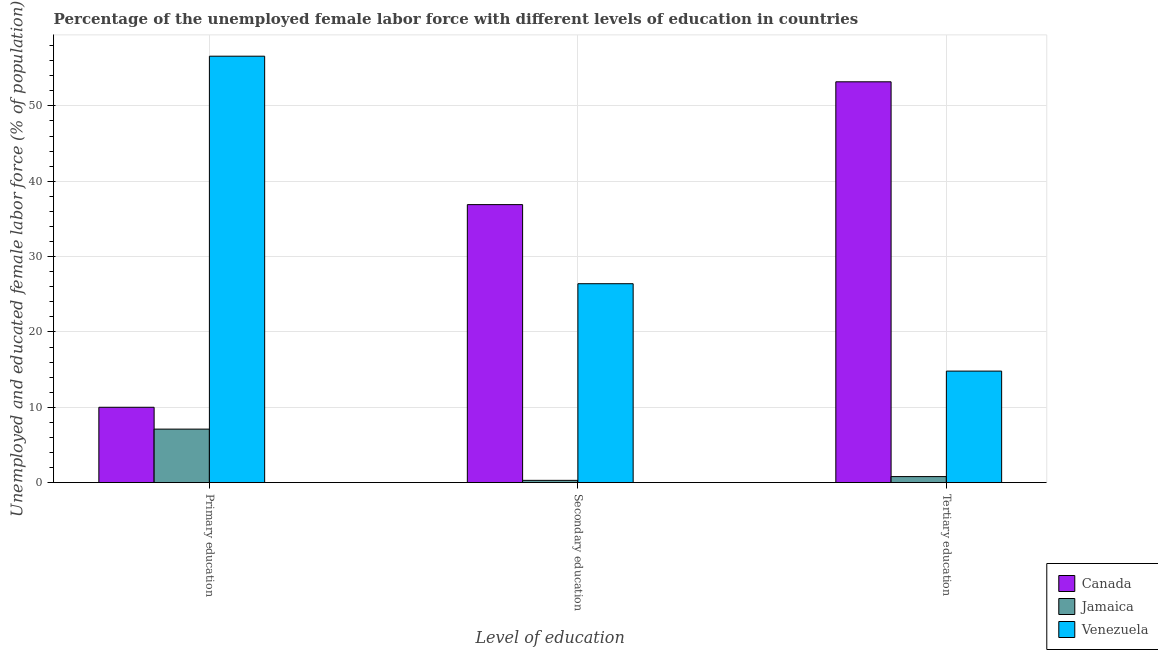How many groups of bars are there?
Provide a short and direct response. 3. Are the number of bars on each tick of the X-axis equal?
Your answer should be compact. Yes. How many bars are there on the 1st tick from the right?
Offer a very short reply. 3. What is the label of the 2nd group of bars from the left?
Give a very brief answer. Secondary education. What is the percentage of female labor force who received tertiary education in Venezuela?
Offer a very short reply. 14.8. Across all countries, what is the maximum percentage of female labor force who received primary education?
Make the answer very short. 56.6. Across all countries, what is the minimum percentage of female labor force who received secondary education?
Your answer should be compact. 0.3. In which country was the percentage of female labor force who received secondary education maximum?
Your response must be concise. Canada. In which country was the percentage of female labor force who received secondary education minimum?
Make the answer very short. Jamaica. What is the total percentage of female labor force who received secondary education in the graph?
Keep it short and to the point. 63.6. What is the difference between the percentage of female labor force who received tertiary education in Jamaica and that in Venezuela?
Make the answer very short. -14. What is the difference between the percentage of female labor force who received tertiary education in Venezuela and the percentage of female labor force who received primary education in Jamaica?
Offer a terse response. 7.7. What is the average percentage of female labor force who received primary education per country?
Your answer should be compact. 24.57. What is the difference between the percentage of female labor force who received secondary education and percentage of female labor force who received tertiary education in Venezuela?
Ensure brevity in your answer.  11.6. What is the ratio of the percentage of female labor force who received primary education in Canada to that in Jamaica?
Offer a very short reply. 1.41. What is the difference between the highest and the second highest percentage of female labor force who received primary education?
Make the answer very short. 46.6. What is the difference between the highest and the lowest percentage of female labor force who received secondary education?
Keep it short and to the point. 36.6. Is the sum of the percentage of female labor force who received secondary education in Jamaica and Venezuela greater than the maximum percentage of female labor force who received primary education across all countries?
Keep it short and to the point. No. What does the 2nd bar from the right in Tertiary education represents?
Make the answer very short. Jamaica. Are all the bars in the graph horizontal?
Your answer should be very brief. No. What is the difference between two consecutive major ticks on the Y-axis?
Provide a succinct answer. 10. Does the graph contain any zero values?
Provide a succinct answer. No. Where does the legend appear in the graph?
Offer a terse response. Bottom right. How many legend labels are there?
Your response must be concise. 3. How are the legend labels stacked?
Keep it short and to the point. Vertical. What is the title of the graph?
Provide a succinct answer. Percentage of the unemployed female labor force with different levels of education in countries. Does "St. Martin (French part)" appear as one of the legend labels in the graph?
Give a very brief answer. No. What is the label or title of the X-axis?
Give a very brief answer. Level of education. What is the label or title of the Y-axis?
Give a very brief answer. Unemployed and educated female labor force (% of population). What is the Unemployed and educated female labor force (% of population) of Canada in Primary education?
Give a very brief answer. 10. What is the Unemployed and educated female labor force (% of population) in Jamaica in Primary education?
Ensure brevity in your answer.  7.1. What is the Unemployed and educated female labor force (% of population) in Venezuela in Primary education?
Offer a terse response. 56.6. What is the Unemployed and educated female labor force (% of population) of Canada in Secondary education?
Keep it short and to the point. 36.9. What is the Unemployed and educated female labor force (% of population) of Jamaica in Secondary education?
Give a very brief answer. 0.3. What is the Unemployed and educated female labor force (% of population) of Venezuela in Secondary education?
Give a very brief answer. 26.4. What is the Unemployed and educated female labor force (% of population) in Canada in Tertiary education?
Provide a succinct answer. 53.2. What is the Unemployed and educated female labor force (% of population) of Jamaica in Tertiary education?
Provide a short and direct response. 0.8. What is the Unemployed and educated female labor force (% of population) of Venezuela in Tertiary education?
Give a very brief answer. 14.8. Across all Level of education, what is the maximum Unemployed and educated female labor force (% of population) of Canada?
Your response must be concise. 53.2. Across all Level of education, what is the maximum Unemployed and educated female labor force (% of population) in Jamaica?
Provide a succinct answer. 7.1. Across all Level of education, what is the maximum Unemployed and educated female labor force (% of population) in Venezuela?
Keep it short and to the point. 56.6. Across all Level of education, what is the minimum Unemployed and educated female labor force (% of population) of Canada?
Give a very brief answer. 10. Across all Level of education, what is the minimum Unemployed and educated female labor force (% of population) of Jamaica?
Provide a succinct answer. 0.3. Across all Level of education, what is the minimum Unemployed and educated female labor force (% of population) of Venezuela?
Offer a very short reply. 14.8. What is the total Unemployed and educated female labor force (% of population) of Canada in the graph?
Ensure brevity in your answer.  100.1. What is the total Unemployed and educated female labor force (% of population) in Venezuela in the graph?
Your answer should be very brief. 97.8. What is the difference between the Unemployed and educated female labor force (% of population) in Canada in Primary education and that in Secondary education?
Your answer should be very brief. -26.9. What is the difference between the Unemployed and educated female labor force (% of population) in Venezuela in Primary education and that in Secondary education?
Offer a terse response. 30.2. What is the difference between the Unemployed and educated female labor force (% of population) in Canada in Primary education and that in Tertiary education?
Offer a very short reply. -43.2. What is the difference between the Unemployed and educated female labor force (% of population) in Jamaica in Primary education and that in Tertiary education?
Offer a very short reply. 6.3. What is the difference between the Unemployed and educated female labor force (% of population) of Venezuela in Primary education and that in Tertiary education?
Offer a terse response. 41.8. What is the difference between the Unemployed and educated female labor force (% of population) of Canada in Secondary education and that in Tertiary education?
Give a very brief answer. -16.3. What is the difference between the Unemployed and educated female labor force (% of population) in Venezuela in Secondary education and that in Tertiary education?
Ensure brevity in your answer.  11.6. What is the difference between the Unemployed and educated female labor force (% of population) of Canada in Primary education and the Unemployed and educated female labor force (% of population) of Jamaica in Secondary education?
Provide a succinct answer. 9.7. What is the difference between the Unemployed and educated female labor force (% of population) in Canada in Primary education and the Unemployed and educated female labor force (% of population) in Venezuela in Secondary education?
Your answer should be very brief. -16.4. What is the difference between the Unemployed and educated female labor force (% of population) in Jamaica in Primary education and the Unemployed and educated female labor force (% of population) in Venezuela in Secondary education?
Offer a terse response. -19.3. What is the difference between the Unemployed and educated female labor force (% of population) of Canada in Secondary education and the Unemployed and educated female labor force (% of population) of Jamaica in Tertiary education?
Your answer should be compact. 36.1. What is the difference between the Unemployed and educated female labor force (% of population) in Canada in Secondary education and the Unemployed and educated female labor force (% of population) in Venezuela in Tertiary education?
Provide a succinct answer. 22.1. What is the difference between the Unemployed and educated female labor force (% of population) in Jamaica in Secondary education and the Unemployed and educated female labor force (% of population) in Venezuela in Tertiary education?
Your answer should be very brief. -14.5. What is the average Unemployed and educated female labor force (% of population) in Canada per Level of education?
Give a very brief answer. 33.37. What is the average Unemployed and educated female labor force (% of population) in Jamaica per Level of education?
Your answer should be very brief. 2.73. What is the average Unemployed and educated female labor force (% of population) of Venezuela per Level of education?
Provide a short and direct response. 32.6. What is the difference between the Unemployed and educated female labor force (% of population) in Canada and Unemployed and educated female labor force (% of population) in Venezuela in Primary education?
Give a very brief answer. -46.6. What is the difference between the Unemployed and educated female labor force (% of population) of Jamaica and Unemployed and educated female labor force (% of population) of Venezuela in Primary education?
Your answer should be very brief. -49.5. What is the difference between the Unemployed and educated female labor force (% of population) of Canada and Unemployed and educated female labor force (% of population) of Jamaica in Secondary education?
Offer a very short reply. 36.6. What is the difference between the Unemployed and educated female labor force (% of population) of Jamaica and Unemployed and educated female labor force (% of population) of Venezuela in Secondary education?
Your answer should be compact. -26.1. What is the difference between the Unemployed and educated female labor force (% of population) in Canada and Unemployed and educated female labor force (% of population) in Jamaica in Tertiary education?
Give a very brief answer. 52.4. What is the difference between the Unemployed and educated female labor force (% of population) of Canada and Unemployed and educated female labor force (% of population) of Venezuela in Tertiary education?
Provide a short and direct response. 38.4. What is the ratio of the Unemployed and educated female labor force (% of population) of Canada in Primary education to that in Secondary education?
Offer a very short reply. 0.27. What is the ratio of the Unemployed and educated female labor force (% of population) of Jamaica in Primary education to that in Secondary education?
Your answer should be compact. 23.67. What is the ratio of the Unemployed and educated female labor force (% of population) of Venezuela in Primary education to that in Secondary education?
Your response must be concise. 2.14. What is the ratio of the Unemployed and educated female labor force (% of population) of Canada in Primary education to that in Tertiary education?
Offer a terse response. 0.19. What is the ratio of the Unemployed and educated female labor force (% of population) of Jamaica in Primary education to that in Tertiary education?
Give a very brief answer. 8.88. What is the ratio of the Unemployed and educated female labor force (% of population) in Venezuela in Primary education to that in Tertiary education?
Provide a short and direct response. 3.82. What is the ratio of the Unemployed and educated female labor force (% of population) in Canada in Secondary education to that in Tertiary education?
Your answer should be compact. 0.69. What is the ratio of the Unemployed and educated female labor force (% of population) of Jamaica in Secondary education to that in Tertiary education?
Provide a succinct answer. 0.38. What is the ratio of the Unemployed and educated female labor force (% of population) in Venezuela in Secondary education to that in Tertiary education?
Provide a succinct answer. 1.78. What is the difference between the highest and the second highest Unemployed and educated female labor force (% of population) in Canada?
Your answer should be compact. 16.3. What is the difference between the highest and the second highest Unemployed and educated female labor force (% of population) in Venezuela?
Keep it short and to the point. 30.2. What is the difference between the highest and the lowest Unemployed and educated female labor force (% of population) in Canada?
Your answer should be compact. 43.2. What is the difference between the highest and the lowest Unemployed and educated female labor force (% of population) of Jamaica?
Offer a terse response. 6.8. What is the difference between the highest and the lowest Unemployed and educated female labor force (% of population) of Venezuela?
Ensure brevity in your answer.  41.8. 